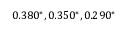<formula> <loc_0><loc_0><loc_500><loc_500>0 . 3 8 0 ^ { * } , 0 . 3 5 0 ^ { * } , 0 . 2 9 0 ^ { * }</formula> 